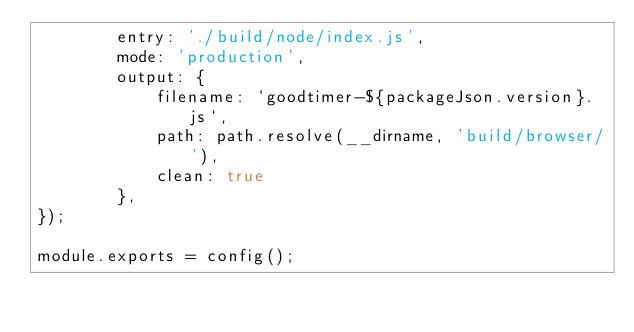<code> <loc_0><loc_0><loc_500><loc_500><_JavaScript_>        entry: './build/node/index.js',
        mode: 'production',
        output: {
            filename: `goodtimer-${packageJson.version}.js`,
            path: path.resolve(__dirname, 'build/browser/'),
            clean: true
        },
});

module.exports = config();
</code> 